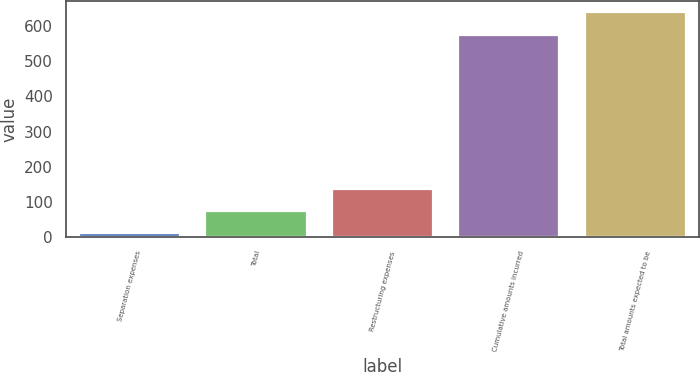Convert chart. <chart><loc_0><loc_0><loc_500><loc_500><bar_chart><fcel>Separation expenses<fcel>Total<fcel>Restructuring expenses<fcel>Cumulative amounts incurred<fcel>Total amounts expected to be<nl><fcel>11<fcel>73.7<fcel>138<fcel>573<fcel>638<nl></chart> 